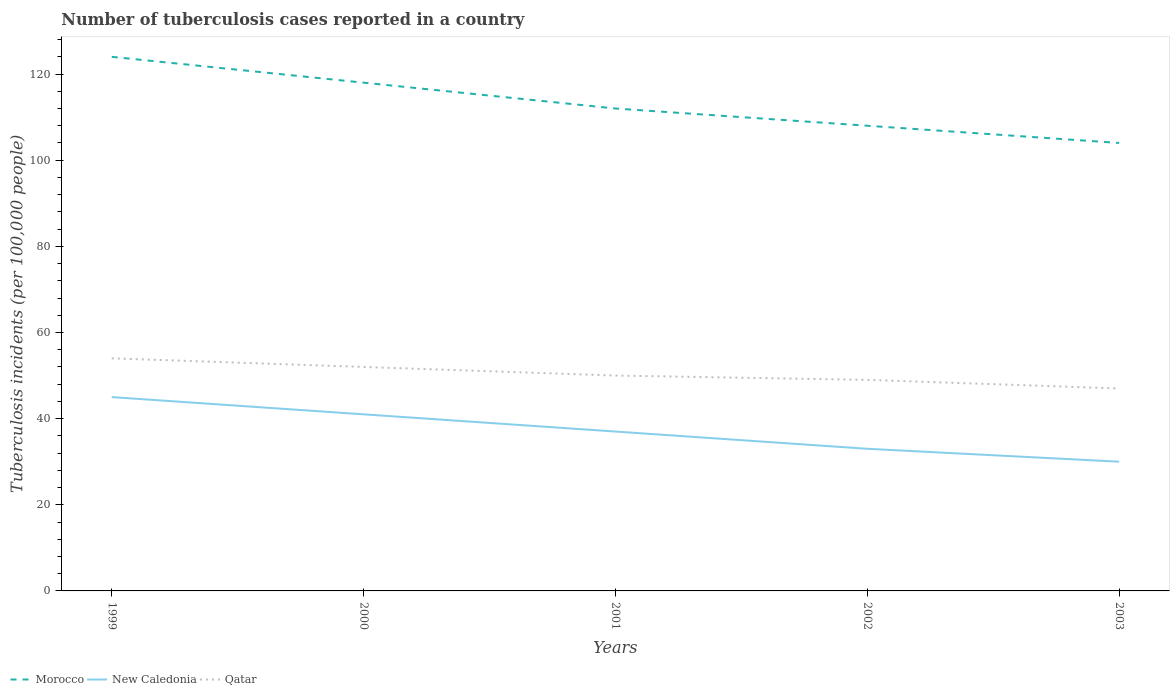Across all years, what is the maximum number of tuberculosis cases reported in in Morocco?
Make the answer very short. 104. In which year was the number of tuberculosis cases reported in in Morocco maximum?
Ensure brevity in your answer.  2003. What is the total number of tuberculosis cases reported in in Morocco in the graph?
Keep it short and to the point. 6. What is the difference between the highest and the second highest number of tuberculosis cases reported in in New Caledonia?
Keep it short and to the point. 15. What is the difference between the highest and the lowest number of tuberculosis cases reported in in Morocco?
Your answer should be very brief. 2. How many years are there in the graph?
Your answer should be compact. 5. What is the difference between two consecutive major ticks on the Y-axis?
Offer a terse response. 20. Are the values on the major ticks of Y-axis written in scientific E-notation?
Offer a very short reply. No. How are the legend labels stacked?
Give a very brief answer. Horizontal. What is the title of the graph?
Keep it short and to the point. Number of tuberculosis cases reported in a country. What is the label or title of the Y-axis?
Your response must be concise. Tuberculosis incidents (per 100,0 people). What is the Tuberculosis incidents (per 100,000 people) of Morocco in 1999?
Make the answer very short. 124. What is the Tuberculosis incidents (per 100,000 people) of Qatar in 1999?
Keep it short and to the point. 54. What is the Tuberculosis incidents (per 100,000 people) in Morocco in 2000?
Provide a succinct answer. 118. What is the Tuberculosis incidents (per 100,000 people) of Morocco in 2001?
Your response must be concise. 112. What is the Tuberculosis incidents (per 100,000 people) of Morocco in 2002?
Your answer should be compact. 108. What is the Tuberculosis incidents (per 100,000 people) of Qatar in 2002?
Your answer should be compact. 49. What is the Tuberculosis incidents (per 100,000 people) of Morocco in 2003?
Ensure brevity in your answer.  104. What is the Tuberculosis incidents (per 100,000 people) of New Caledonia in 2003?
Make the answer very short. 30. Across all years, what is the maximum Tuberculosis incidents (per 100,000 people) of Morocco?
Offer a very short reply. 124. Across all years, what is the minimum Tuberculosis incidents (per 100,000 people) of Morocco?
Your answer should be compact. 104. Across all years, what is the minimum Tuberculosis incidents (per 100,000 people) of New Caledonia?
Your response must be concise. 30. Across all years, what is the minimum Tuberculosis incidents (per 100,000 people) in Qatar?
Your response must be concise. 47. What is the total Tuberculosis incidents (per 100,000 people) in Morocco in the graph?
Give a very brief answer. 566. What is the total Tuberculosis incidents (per 100,000 people) of New Caledonia in the graph?
Offer a very short reply. 186. What is the total Tuberculosis incidents (per 100,000 people) in Qatar in the graph?
Provide a succinct answer. 252. What is the difference between the Tuberculosis incidents (per 100,000 people) in New Caledonia in 1999 and that in 2000?
Keep it short and to the point. 4. What is the difference between the Tuberculosis incidents (per 100,000 people) of Qatar in 1999 and that in 2000?
Make the answer very short. 2. What is the difference between the Tuberculosis incidents (per 100,000 people) of Morocco in 1999 and that in 2001?
Give a very brief answer. 12. What is the difference between the Tuberculosis incidents (per 100,000 people) in Morocco in 1999 and that in 2002?
Your response must be concise. 16. What is the difference between the Tuberculosis incidents (per 100,000 people) in New Caledonia in 1999 and that in 2002?
Provide a short and direct response. 12. What is the difference between the Tuberculosis incidents (per 100,000 people) of Morocco in 1999 and that in 2003?
Keep it short and to the point. 20. What is the difference between the Tuberculosis incidents (per 100,000 people) in New Caledonia in 1999 and that in 2003?
Your answer should be very brief. 15. What is the difference between the Tuberculosis incidents (per 100,000 people) in Qatar in 1999 and that in 2003?
Keep it short and to the point. 7. What is the difference between the Tuberculosis incidents (per 100,000 people) in Morocco in 2000 and that in 2001?
Give a very brief answer. 6. What is the difference between the Tuberculosis incidents (per 100,000 people) in New Caledonia in 2000 and that in 2001?
Provide a succinct answer. 4. What is the difference between the Tuberculosis incidents (per 100,000 people) of Qatar in 2000 and that in 2001?
Keep it short and to the point. 2. What is the difference between the Tuberculosis incidents (per 100,000 people) of New Caledonia in 2000 and that in 2002?
Your answer should be very brief. 8. What is the difference between the Tuberculosis incidents (per 100,000 people) in Qatar in 2000 and that in 2002?
Your answer should be very brief. 3. What is the difference between the Tuberculosis incidents (per 100,000 people) of Morocco in 2000 and that in 2003?
Ensure brevity in your answer.  14. What is the difference between the Tuberculosis incidents (per 100,000 people) in New Caledonia in 2000 and that in 2003?
Keep it short and to the point. 11. What is the difference between the Tuberculosis incidents (per 100,000 people) in New Caledonia in 2001 and that in 2002?
Keep it short and to the point. 4. What is the difference between the Tuberculosis incidents (per 100,000 people) of Morocco in 2001 and that in 2003?
Your answer should be compact. 8. What is the difference between the Tuberculosis incidents (per 100,000 people) in New Caledonia in 2001 and that in 2003?
Make the answer very short. 7. What is the difference between the Tuberculosis incidents (per 100,000 people) in Morocco in 1999 and the Tuberculosis incidents (per 100,000 people) in New Caledonia in 2000?
Your answer should be very brief. 83. What is the difference between the Tuberculosis incidents (per 100,000 people) of New Caledonia in 1999 and the Tuberculosis incidents (per 100,000 people) of Qatar in 2000?
Provide a succinct answer. -7. What is the difference between the Tuberculosis incidents (per 100,000 people) in Morocco in 1999 and the Tuberculosis incidents (per 100,000 people) in New Caledonia in 2002?
Your answer should be compact. 91. What is the difference between the Tuberculosis incidents (per 100,000 people) in Morocco in 1999 and the Tuberculosis incidents (per 100,000 people) in Qatar in 2002?
Give a very brief answer. 75. What is the difference between the Tuberculosis incidents (per 100,000 people) of Morocco in 1999 and the Tuberculosis incidents (per 100,000 people) of New Caledonia in 2003?
Provide a short and direct response. 94. What is the difference between the Tuberculosis incidents (per 100,000 people) of Morocco in 1999 and the Tuberculosis incidents (per 100,000 people) of Qatar in 2003?
Provide a short and direct response. 77. What is the difference between the Tuberculosis incidents (per 100,000 people) in Morocco in 2000 and the Tuberculosis incidents (per 100,000 people) in Qatar in 2001?
Ensure brevity in your answer.  68. What is the difference between the Tuberculosis incidents (per 100,000 people) in New Caledonia in 2000 and the Tuberculosis incidents (per 100,000 people) in Qatar in 2001?
Keep it short and to the point. -9. What is the difference between the Tuberculosis incidents (per 100,000 people) in Morocco in 2000 and the Tuberculosis incidents (per 100,000 people) in New Caledonia in 2002?
Your response must be concise. 85. What is the difference between the Tuberculosis incidents (per 100,000 people) of Morocco in 2000 and the Tuberculosis incidents (per 100,000 people) of Qatar in 2002?
Make the answer very short. 69. What is the difference between the Tuberculosis incidents (per 100,000 people) of New Caledonia in 2000 and the Tuberculosis incidents (per 100,000 people) of Qatar in 2002?
Provide a succinct answer. -8. What is the difference between the Tuberculosis incidents (per 100,000 people) in Morocco in 2000 and the Tuberculosis incidents (per 100,000 people) in New Caledonia in 2003?
Give a very brief answer. 88. What is the difference between the Tuberculosis incidents (per 100,000 people) in Morocco in 2000 and the Tuberculosis incidents (per 100,000 people) in Qatar in 2003?
Your answer should be very brief. 71. What is the difference between the Tuberculosis incidents (per 100,000 people) in New Caledonia in 2000 and the Tuberculosis incidents (per 100,000 people) in Qatar in 2003?
Ensure brevity in your answer.  -6. What is the difference between the Tuberculosis incidents (per 100,000 people) in Morocco in 2001 and the Tuberculosis incidents (per 100,000 people) in New Caledonia in 2002?
Keep it short and to the point. 79. What is the difference between the Tuberculosis incidents (per 100,000 people) in Morocco in 2001 and the Tuberculosis incidents (per 100,000 people) in Qatar in 2002?
Your answer should be compact. 63. What is the difference between the Tuberculosis incidents (per 100,000 people) in Morocco in 2001 and the Tuberculosis incidents (per 100,000 people) in Qatar in 2003?
Provide a succinct answer. 65. What is the average Tuberculosis incidents (per 100,000 people) of Morocco per year?
Ensure brevity in your answer.  113.2. What is the average Tuberculosis incidents (per 100,000 people) in New Caledonia per year?
Offer a terse response. 37.2. What is the average Tuberculosis incidents (per 100,000 people) in Qatar per year?
Give a very brief answer. 50.4. In the year 1999, what is the difference between the Tuberculosis incidents (per 100,000 people) in Morocco and Tuberculosis incidents (per 100,000 people) in New Caledonia?
Give a very brief answer. 79. In the year 1999, what is the difference between the Tuberculosis incidents (per 100,000 people) of Morocco and Tuberculosis incidents (per 100,000 people) of Qatar?
Offer a terse response. 70. In the year 2000, what is the difference between the Tuberculosis incidents (per 100,000 people) in Morocco and Tuberculosis incidents (per 100,000 people) in New Caledonia?
Provide a short and direct response. 77. In the year 2001, what is the difference between the Tuberculosis incidents (per 100,000 people) of Morocco and Tuberculosis incidents (per 100,000 people) of Qatar?
Your response must be concise. 62. In the year 2001, what is the difference between the Tuberculosis incidents (per 100,000 people) in New Caledonia and Tuberculosis incidents (per 100,000 people) in Qatar?
Your answer should be very brief. -13. In the year 2002, what is the difference between the Tuberculosis incidents (per 100,000 people) in Morocco and Tuberculosis incidents (per 100,000 people) in Qatar?
Your answer should be very brief. 59. In the year 2002, what is the difference between the Tuberculosis incidents (per 100,000 people) of New Caledonia and Tuberculosis incidents (per 100,000 people) of Qatar?
Give a very brief answer. -16. In the year 2003, what is the difference between the Tuberculosis incidents (per 100,000 people) in Morocco and Tuberculosis incidents (per 100,000 people) in Qatar?
Keep it short and to the point. 57. What is the ratio of the Tuberculosis incidents (per 100,000 people) in Morocco in 1999 to that in 2000?
Keep it short and to the point. 1.05. What is the ratio of the Tuberculosis incidents (per 100,000 people) of New Caledonia in 1999 to that in 2000?
Give a very brief answer. 1.1. What is the ratio of the Tuberculosis incidents (per 100,000 people) of Qatar in 1999 to that in 2000?
Keep it short and to the point. 1.04. What is the ratio of the Tuberculosis incidents (per 100,000 people) of Morocco in 1999 to that in 2001?
Ensure brevity in your answer.  1.11. What is the ratio of the Tuberculosis incidents (per 100,000 people) of New Caledonia in 1999 to that in 2001?
Provide a succinct answer. 1.22. What is the ratio of the Tuberculosis incidents (per 100,000 people) of Morocco in 1999 to that in 2002?
Ensure brevity in your answer.  1.15. What is the ratio of the Tuberculosis incidents (per 100,000 people) of New Caledonia in 1999 to that in 2002?
Your answer should be very brief. 1.36. What is the ratio of the Tuberculosis incidents (per 100,000 people) in Qatar in 1999 to that in 2002?
Give a very brief answer. 1.1. What is the ratio of the Tuberculosis incidents (per 100,000 people) in Morocco in 1999 to that in 2003?
Offer a terse response. 1.19. What is the ratio of the Tuberculosis incidents (per 100,000 people) of New Caledonia in 1999 to that in 2003?
Make the answer very short. 1.5. What is the ratio of the Tuberculosis incidents (per 100,000 people) of Qatar in 1999 to that in 2003?
Make the answer very short. 1.15. What is the ratio of the Tuberculosis incidents (per 100,000 people) in Morocco in 2000 to that in 2001?
Ensure brevity in your answer.  1.05. What is the ratio of the Tuberculosis incidents (per 100,000 people) in New Caledonia in 2000 to that in 2001?
Your answer should be compact. 1.11. What is the ratio of the Tuberculosis incidents (per 100,000 people) in Qatar in 2000 to that in 2001?
Ensure brevity in your answer.  1.04. What is the ratio of the Tuberculosis incidents (per 100,000 people) in Morocco in 2000 to that in 2002?
Ensure brevity in your answer.  1.09. What is the ratio of the Tuberculosis incidents (per 100,000 people) in New Caledonia in 2000 to that in 2002?
Your answer should be very brief. 1.24. What is the ratio of the Tuberculosis incidents (per 100,000 people) in Qatar in 2000 to that in 2002?
Ensure brevity in your answer.  1.06. What is the ratio of the Tuberculosis incidents (per 100,000 people) in Morocco in 2000 to that in 2003?
Offer a terse response. 1.13. What is the ratio of the Tuberculosis incidents (per 100,000 people) in New Caledonia in 2000 to that in 2003?
Your answer should be very brief. 1.37. What is the ratio of the Tuberculosis incidents (per 100,000 people) of Qatar in 2000 to that in 2003?
Ensure brevity in your answer.  1.11. What is the ratio of the Tuberculosis incidents (per 100,000 people) in New Caledonia in 2001 to that in 2002?
Your answer should be very brief. 1.12. What is the ratio of the Tuberculosis incidents (per 100,000 people) in Qatar in 2001 to that in 2002?
Offer a terse response. 1.02. What is the ratio of the Tuberculosis incidents (per 100,000 people) of Morocco in 2001 to that in 2003?
Your response must be concise. 1.08. What is the ratio of the Tuberculosis incidents (per 100,000 people) of New Caledonia in 2001 to that in 2003?
Your answer should be very brief. 1.23. What is the ratio of the Tuberculosis incidents (per 100,000 people) of Qatar in 2001 to that in 2003?
Keep it short and to the point. 1.06. What is the ratio of the Tuberculosis incidents (per 100,000 people) in New Caledonia in 2002 to that in 2003?
Your answer should be very brief. 1.1. What is the ratio of the Tuberculosis incidents (per 100,000 people) of Qatar in 2002 to that in 2003?
Provide a short and direct response. 1.04. What is the difference between the highest and the second highest Tuberculosis incidents (per 100,000 people) of New Caledonia?
Offer a terse response. 4. 